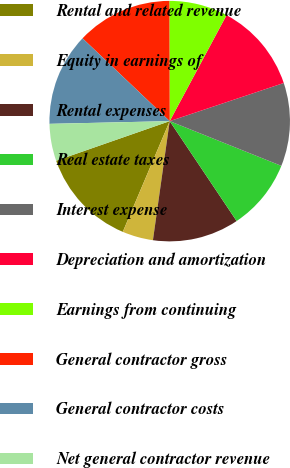Convert chart. <chart><loc_0><loc_0><loc_500><loc_500><pie_chart><fcel>Rental and related revenue<fcel>Equity in earnings of<fcel>Rental expenses<fcel>Real estate taxes<fcel>Interest expense<fcel>Depreciation and amortization<fcel>Earnings from continuing<fcel>General contractor gross<fcel>General contractor costs<fcel>Net general contractor revenue<nl><fcel>13.28%<fcel>4.15%<fcel>11.62%<fcel>9.54%<fcel>11.2%<fcel>12.03%<fcel>7.88%<fcel>12.86%<fcel>12.45%<fcel>4.98%<nl></chart> 